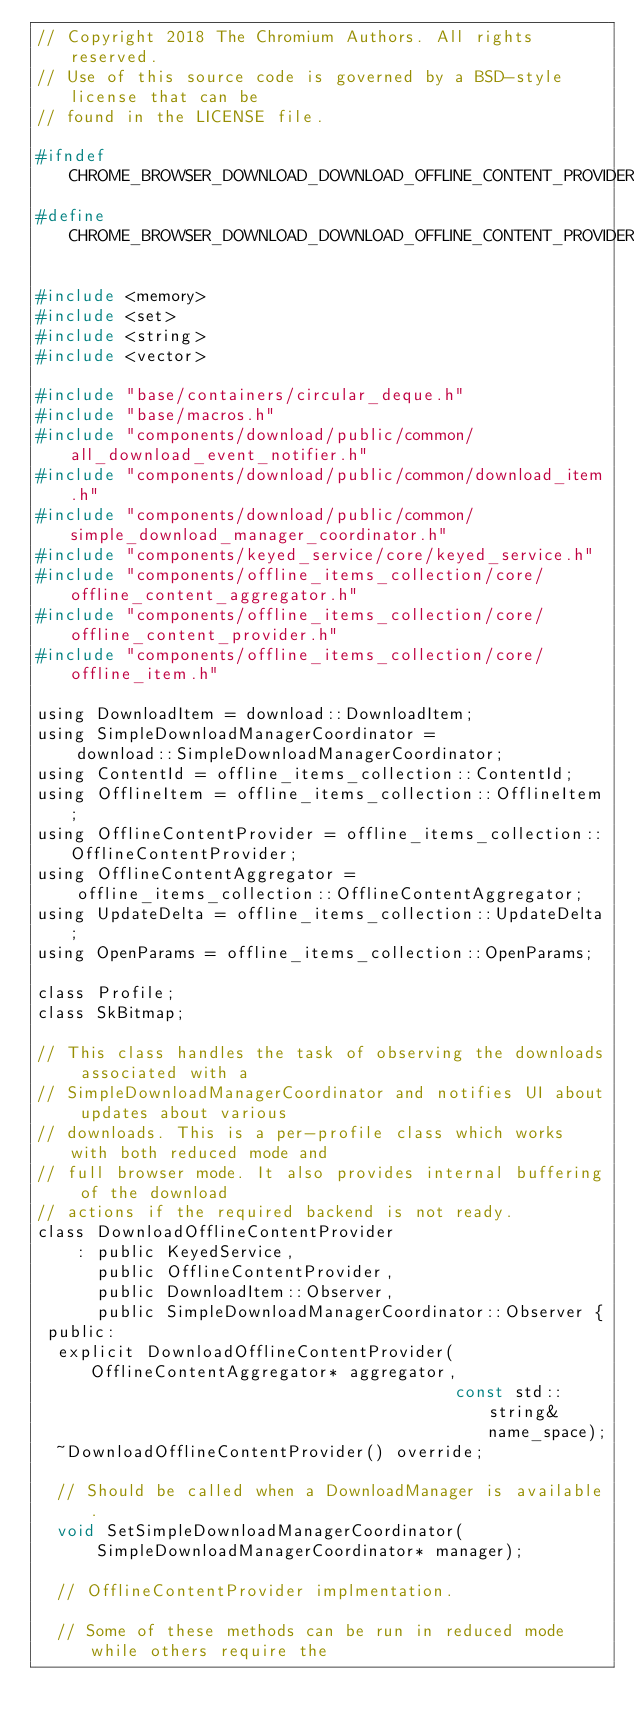Convert code to text. <code><loc_0><loc_0><loc_500><loc_500><_C_>// Copyright 2018 The Chromium Authors. All rights reserved.
// Use of this source code is governed by a BSD-style license that can be
// found in the LICENSE file.

#ifndef CHROME_BROWSER_DOWNLOAD_DOWNLOAD_OFFLINE_CONTENT_PROVIDER_H_
#define CHROME_BROWSER_DOWNLOAD_DOWNLOAD_OFFLINE_CONTENT_PROVIDER_H_

#include <memory>
#include <set>
#include <string>
#include <vector>

#include "base/containers/circular_deque.h"
#include "base/macros.h"
#include "components/download/public/common/all_download_event_notifier.h"
#include "components/download/public/common/download_item.h"
#include "components/download/public/common/simple_download_manager_coordinator.h"
#include "components/keyed_service/core/keyed_service.h"
#include "components/offline_items_collection/core/offline_content_aggregator.h"
#include "components/offline_items_collection/core/offline_content_provider.h"
#include "components/offline_items_collection/core/offline_item.h"

using DownloadItem = download::DownloadItem;
using SimpleDownloadManagerCoordinator =
    download::SimpleDownloadManagerCoordinator;
using ContentId = offline_items_collection::ContentId;
using OfflineItem = offline_items_collection::OfflineItem;
using OfflineContentProvider = offline_items_collection::OfflineContentProvider;
using OfflineContentAggregator =
    offline_items_collection::OfflineContentAggregator;
using UpdateDelta = offline_items_collection::UpdateDelta;
using OpenParams = offline_items_collection::OpenParams;

class Profile;
class SkBitmap;

// This class handles the task of observing the downloads associated with a
// SimpleDownloadManagerCoordinator and notifies UI about updates about various
// downloads. This is a per-profile class which works with both reduced mode and
// full browser mode. It also provides internal buffering of the download
// actions if the required backend is not ready.
class DownloadOfflineContentProvider
    : public KeyedService,
      public OfflineContentProvider,
      public DownloadItem::Observer,
      public SimpleDownloadManagerCoordinator::Observer {
 public:
  explicit DownloadOfflineContentProvider(OfflineContentAggregator* aggregator,
                                          const std::string& name_space);
  ~DownloadOfflineContentProvider() override;

  // Should be called when a DownloadManager is available.
  void SetSimpleDownloadManagerCoordinator(
      SimpleDownloadManagerCoordinator* manager);

  // OfflineContentProvider implmentation.

  // Some of these methods can be run in reduced mode while others require the</code> 